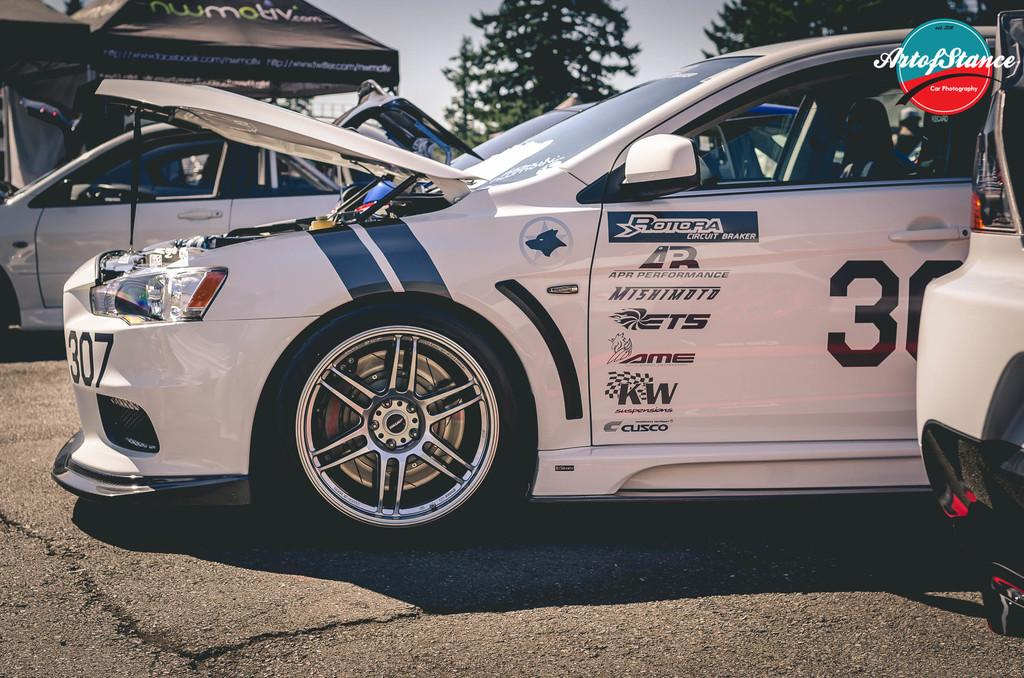What is the main subject in the center of the image? There is a sports car in the center of the image. What can be seen on the right side of the image? There are other cars on the right side of the image. What can be seen on the left side of the image? There are other cars on the left side of the image. What type of natural elements are visible at the top side of the image? There are trees at the top side of the image. Can you tell me how many people are using a rake in the image? There are no people or rakes present in the image. What type of farmer is shown working in the image? There is no farmer present in the image. 